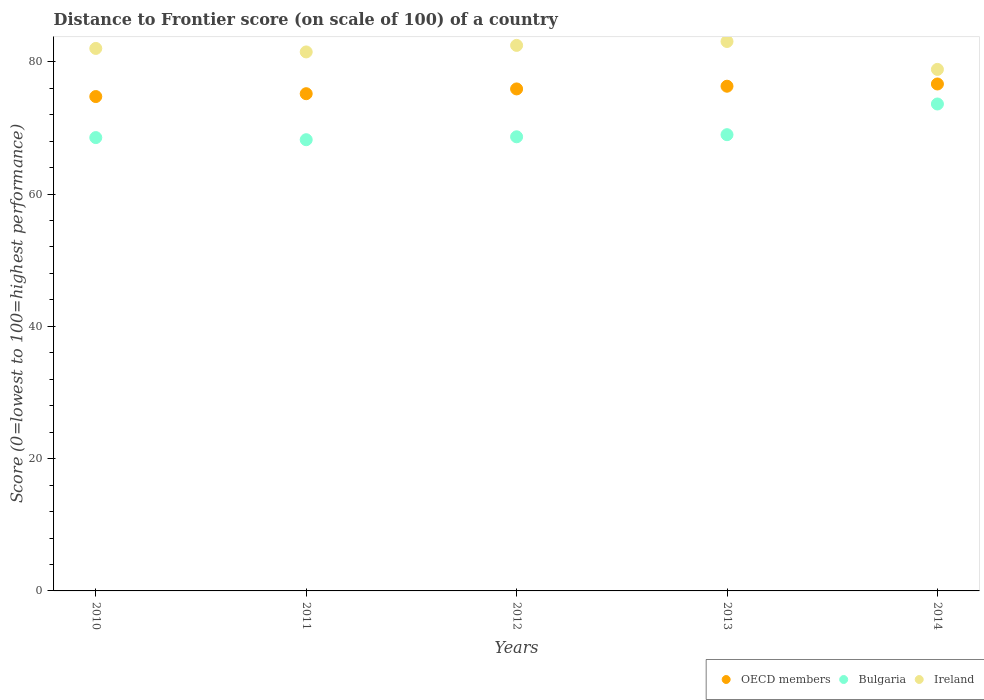What is the distance to frontier score of in Bulgaria in 2014?
Ensure brevity in your answer.  73.62. Across all years, what is the maximum distance to frontier score of in OECD members?
Give a very brief answer. 76.65. Across all years, what is the minimum distance to frontier score of in Bulgaria?
Keep it short and to the point. 68.22. In which year was the distance to frontier score of in OECD members minimum?
Provide a succinct answer. 2010. What is the total distance to frontier score of in OECD members in the graph?
Provide a short and direct response. 378.77. What is the difference between the distance to frontier score of in Bulgaria in 2012 and that in 2013?
Offer a terse response. -0.32. What is the difference between the distance to frontier score of in Ireland in 2011 and the distance to frontier score of in OECD members in 2012?
Provide a succinct answer. 5.59. What is the average distance to frontier score of in Bulgaria per year?
Provide a succinct answer. 69.6. In the year 2014, what is the difference between the distance to frontier score of in Ireland and distance to frontier score of in OECD members?
Your answer should be very brief. 2.2. In how many years, is the distance to frontier score of in OECD members greater than 36?
Offer a very short reply. 5. What is the ratio of the distance to frontier score of in Bulgaria in 2013 to that in 2014?
Your response must be concise. 0.94. Is the distance to frontier score of in OECD members in 2011 less than that in 2013?
Provide a succinct answer. Yes. Is the difference between the distance to frontier score of in Ireland in 2011 and 2012 greater than the difference between the distance to frontier score of in OECD members in 2011 and 2012?
Ensure brevity in your answer.  No. What is the difference between the highest and the second highest distance to frontier score of in OECD members?
Offer a terse response. 0.34. What is the difference between the highest and the lowest distance to frontier score of in Ireland?
Provide a short and direct response. 4.22. Is the sum of the distance to frontier score of in OECD members in 2010 and 2014 greater than the maximum distance to frontier score of in Ireland across all years?
Offer a very short reply. Yes. How many years are there in the graph?
Offer a terse response. 5. What is the difference between two consecutive major ticks on the Y-axis?
Keep it short and to the point. 20. Does the graph contain any zero values?
Make the answer very short. No. Where does the legend appear in the graph?
Your answer should be very brief. Bottom right. What is the title of the graph?
Ensure brevity in your answer.  Distance to Frontier score (on scale of 100) of a country. Does "Zambia" appear as one of the legend labels in the graph?
Offer a very short reply. No. What is the label or title of the Y-axis?
Provide a succinct answer. Score (0=lowest to 100=highest performance). What is the Score (0=lowest to 100=highest performance) in OECD members in 2010?
Your response must be concise. 74.74. What is the Score (0=lowest to 100=highest performance) of Bulgaria in 2010?
Offer a terse response. 68.54. What is the Score (0=lowest to 100=highest performance) of Ireland in 2010?
Your answer should be compact. 82.02. What is the Score (0=lowest to 100=highest performance) in OECD members in 2011?
Your response must be concise. 75.18. What is the Score (0=lowest to 100=highest performance) of Bulgaria in 2011?
Offer a terse response. 68.22. What is the Score (0=lowest to 100=highest performance) of Ireland in 2011?
Ensure brevity in your answer.  81.49. What is the Score (0=lowest to 100=highest performance) in OECD members in 2012?
Offer a very short reply. 75.9. What is the Score (0=lowest to 100=highest performance) of Bulgaria in 2012?
Offer a terse response. 68.66. What is the Score (0=lowest to 100=highest performance) in Ireland in 2012?
Provide a succinct answer. 82.48. What is the Score (0=lowest to 100=highest performance) of OECD members in 2013?
Provide a short and direct response. 76.31. What is the Score (0=lowest to 100=highest performance) in Bulgaria in 2013?
Make the answer very short. 68.98. What is the Score (0=lowest to 100=highest performance) of Ireland in 2013?
Your answer should be compact. 83.07. What is the Score (0=lowest to 100=highest performance) of OECD members in 2014?
Keep it short and to the point. 76.65. What is the Score (0=lowest to 100=highest performance) in Bulgaria in 2014?
Provide a short and direct response. 73.62. What is the Score (0=lowest to 100=highest performance) in Ireland in 2014?
Give a very brief answer. 78.85. Across all years, what is the maximum Score (0=lowest to 100=highest performance) in OECD members?
Your answer should be compact. 76.65. Across all years, what is the maximum Score (0=lowest to 100=highest performance) in Bulgaria?
Offer a terse response. 73.62. Across all years, what is the maximum Score (0=lowest to 100=highest performance) of Ireland?
Ensure brevity in your answer.  83.07. Across all years, what is the minimum Score (0=lowest to 100=highest performance) in OECD members?
Make the answer very short. 74.74. Across all years, what is the minimum Score (0=lowest to 100=highest performance) in Bulgaria?
Keep it short and to the point. 68.22. Across all years, what is the minimum Score (0=lowest to 100=highest performance) of Ireland?
Your response must be concise. 78.85. What is the total Score (0=lowest to 100=highest performance) in OECD members in the graph?
Ensure brevity in your answer.  378.77. What is the total Score (0=lowest to 100=highest performance) of Bulgaria in the graph?
Give a very brief answer. 348.02. What is the total Score (0=lowest to 100=highest performance) in Ireland in the graph?
Ensure brevity in your answer.  407.91. What is the difference between the Score (0=lowest to 100=highest performance) of OECD members in 2010 and that in 2011?
Offer a terse response. -0.43. What is the difference between the Score (0=lowest to 100=highest performance) of Bulgaria in 2010 and that in 2011?
Offer a terse response. 0.32. What is the difference between the Score (0=lowest to 100=highest performance) in Ireland in 2010 and that in 2011?
Your answer should be very brief. 0.53. What is the difference between the Score (0=lowest to 100=highest performance) in OECD members in 2010 and that in 2012?
Your response must be concise. -1.15. What is the difference between the Score (0=lowest to 100=highest performance) in Bulgaria in 2010 and that in 2012?
Keep it short and to the point. -0.12. What is the difference between the Score (0=lowest to 100=highest performance) in Ireland in 2010 and that in 2012?
Provide a short and direct response. -0.46. What is the difference between the Score (0=lowest to 100=highest performance) in OECD members in 2010 and that in 2013?
Give a very brief answer. -1.56. What is the difference between the Score (0=lowest to 100=highest performance) of Bulgaria in 2010 and that in 2013?
Offer a terse response. -0.44. What is the difference between the Score (0=lowest to 100=highest performance) of Ireland in 2010 and that in 2013?
Provide a short and direct response. -1.05. What is the difference between the Score (0=lowest to 100=highest performance) in OECD members in 2010 and that in 2014?
Ensure brevity in your answer.  -1.9. What is the difference between the Score (0=lowest to 100=highest performance) in Bulgaria in 2010 and that in 2014?
Keep it short and to the point. -5.08. What is the difference between the Score (0=lowest to 100=highest performance) in Ireland in 2010 and that in 2014?
Make the answer very short. 3.17. What is the difference between the Score (0=lowest to 100=highest performance) of OECD members in 2011 and that in 2012?
Offer a very short reply. -0.72. What is the difference between the Score (0=lowest to 100=highest performance) in Bulgaria in 2011 and that in 2012?
Provide a succinct answer. -0.44. What is the difference between the Score (0=lowest to 100=highest performance) of Ireland in 2011 and that in 2012?
Keep it short and to the point. -0.99. What is the difference between the Score (0=lowest to 100=highest performance) in OECD members in 2011 and that in 2013?
Offer a very short reply. -1.13. What is the difference between the Score (0=lowest to 100=highest performance) of Bulgaria in 2011 and that in 2013?
Your answer should be very brief. -0.76. What is the difference between the Score (0=lowest to 100=highest performance) in Ireland in 2011 and that in 2013?
Ensure brevity in your answer.  -1.58. What is the difference between the Score (0=lowest to 100=highest performance) of OECD members in 2011 and that in 2014?
Your response must be concise. -1.47. What is the difference between the Score (0=lowest to 100=highest performance) in Bulgaria in 2011 and that in 2014?
Give a very brief answer. -5.4. What is the difference between the Score (0=lowest to 100=highest performance) of Ireland in 2011 and that in 2014?
Make the answer very short. 2.64. What is the difference between the Score (0=lowest to 100=highest performance) of OECD members in 2012 and that in 2013?
Your response must be concise. -0.41. What is the difference between the Score (0=lowest to 100=highest performance) of Bulgaria in 2012 and that in 2013?
Provide a succinct answer. -0.32. What is the difference between the Score (0=lowest to 100=highest performance) of Ireland in 2012 and that in 2013?
Offer a very short reply. -0.59. What is the difference between the Score (0=lowest to 100=highest performance) in OECD members in 2012 and that in 2014?
Give a very brief answer. -0.75. What is the difference between the Score (0=lowest to 100=highest performance) in Bulgaria in 2012 and that in 2014?
Offer a very short reply. -4.96. What is the difference between the Score (0=lowest to 100=highest performance) of Ireland in 2012 and that in 2014?
Offer a very short reply. 3.63. What is the difference between the Score (0=lowest to 100=highest performance) of OECD members in 2013 and that in 2014?
Offer a very short reply. -0.34. What is the difference between the Score (0=lowest to 100=highest performance) of Bulgaria in 2013 and that in 2014?
Ensure brevity in your answer.  -4.64. What is the difference between the Score (0=lowest to 100=highest performance) of Ireland in 2013 and that in 2014?
Offer a terse response. 4.22. What is the difference between the Score (0=lowest to 100=highest performance) of OECD members in 2010 and the Score (0=lowest to 100=highest performance) of Bulgaria in 2011?
Your response must be concise. 6.52. What is the difference between the Score (0=lowest to 100=highest performance) of OECD members in 2010 and the Score (0=lowest to 100=highest performance) of Ireland in 2011?
Your answer should be very brief. -6.75. What is the difference between the Score (0=lowest to 100=highest performance) of Bulgaria in 2010 and the Score (0=lowest to 100=highest performance) of Ireland in 2011?
Provide a succinct answer. -12.95. What is the difference between the Score (0=lowest to 100=highest performance) in OECD members in 2010 and the Score (0=lowest to 100=highest performance) in Bulgaria in 2012?
Your response must be concise. 6.08. What is the difference between the Score (0=lowest to 100=highest performance) of OECD members in 2010 and the Score (0=lowest to 100=highest performance) of Ireland in 2012?
Keep it short and to the point. -7.74. What is the difference between the Score (0=lowest to 100=highest performance) in Bulgaria in 2010 and the Score (0=lowest to 100=highest performance) in Ireland in 2012?
Your answer should be compact. -13.94. What is the difference between the Score (0=lowest to 100=highest performance) of OECD members in 2010 and the Score (0=lowest to 100=highest performance) of Bulgaria in 2013?
Offer a terse response. 5.76. What is the difference between the Score (0=lowest to 100=highest performance) in OECD members in 2010 and the Score (0=lowest to 100=highest performance) in Ireland in 2013?
Give a very brief answer. -8.33. What is the difference between the Score (0=lowest to 100=highest performance) of Bulgaria in 2010 and the Score (0=lowest to 100=highest performance) of Ireland in 2013?
Offer a very short reply. -14.53. What is the difference between the Score (0=lowest to 100=highest performance) in OECD members in 2010 and the Score (0=lowest to 100=highest performance) in Bulgaria in 2014?
Keep it short and to the point. 1.12. What is the difference between the Score (0=lowest to 100=highest performance) in OECD members in 2010 and the Score (0=lowest to 100=highest performance) in Ireland in 2014?
Keep it short and to the point. -4.11. What is the difference between the Score (0=lowest to 100=highest performance) of Bulgaria in 2010 and the Score (0=lowest to 100=highest performance) of Ireland in 2014?
Ensure brevity in your answer.  -10.31. What is the difference between the Score (0=lowest to 100=highest performance) in OECD members in 2011 and the Score (0=lowest to 100=highest performance) in Bulgaria in 2012?
Your answer should be compact. 6.52. What is the difference between the Score (0=lowest to 100=highest performance) in OECD members in 2011 and the Score (0=lowest to 100=highest performance) in Ireland in 2012?
Your response must be concise. -7.3. What is the difference between the Score (0=lowest to 100=highest performance) of Bulgaria in 2011 and the Score (0=lowest to 100=highest performance) of Ireland in 2012?
Ensure brevity in your answer.  -14.26. What is the difference between the Score (0=lowest to 100=highest performance) in OECD members in 2011 and the Score (0=lowest to 100=highest performance) in Bulgaria in 2013?
Give a very brief answer. 6.2. What is the difference between the Score (0=lowest to 100=highest performance) of OECD members in 2011 and the Score (0=lowest to 100=highest performance) of Ireland in 2013?
Give a very brief answer. -7.89. What is the difference between the Score (0=lowest to 100=highest performance) in Bulgaria in 2011 and the Score (0=lowest to 100=highest performance) in Ireland in 2013?
Your answer should be very brief. -14.85. What is the difference between the Score (0=lowest to 100=highest performance) of OECD members in 2011 and the Score (0=lowest to 100=highest performance) of Bulgaria in 2014?
Your answer should be compact. 1.56. What is the difference between the Score (0=lowest to 100=highest performance) of OECD members in 2011 and the Score (0=lowest to 100=highest performance) of Ireland in 2014?
Keep it short and to the point. -3.67. What is the difference between the Score (0=lowest to 100=highest performance) of Bulgaria in 2011 and the Score (0=lowest to 100=highest performance) of Ireland in 2014?
Your response must be concise. -10.63. What is the difference between the Score (0=lowest to 100=highest performance) in OECD members in 2012 and the Score (0=lowest to 100=highest performance) in Bulgaria in 2013?
Your answer should be very brief. 6.92. What is the difference between the Score (0=lowest to 100=highest performance) of OECD members in 2012 and the Score (0=lowest to 100=highest performance) of Ireland in 2013?
Your response must be concise. -7.17. What is the difference between the Score (0=lowest to 100=highest performance) of Bulgaria in 2012 and the Score (0=lowest to 100=highest performance) of Ireland in 2013?
Make the answer very short. -14.41. What is the difference between the Score (0=lowest to 100=highest performance) in OECD members in 2012 and the Score (0=lowest to 100=highest performance) in Bulgaria in 2014?
Make the answer very short. 2.28. What is the difference between the Score (0=lowest to 100=highest performance) of OECD members in 2012 and the Score (0=lowest to 100=highest performance) of Ireland in 2014?
Ensure brevity in your answer.  -2.95. What is the difference between the Score (0=lowest to 100=highest performance) in Bulgaria in 2012 and the Score (0=lowest to 100=highest performance) in Ireland in 2014?
Offer a very short reply. -10.19. What is the difference between the Score (0=lowest to 100=highest performance) in OECD members in 2013 and the Score (0=lowest to 100=highest performance) in Bulgaria in 2014?
Make the answer very short. 2.69. What is the difference between the Score (0=lowest to 100=highest performance) in OECD members in 2013 and the Score (0=lowest to 100=highest performance) in Ireland in 2014?
Offer a terse response. -2.54. What is the difference between the Score (0=lowest to 100=highest performance) of Bulgaria in 2013 and the Score (0=lowest to 100=highest performance) of Ireland in 2014?
Offer a very short reply. -9.87. What is the average Score (0=lowest to 100=highest performance) of OECD members per year?
Make the answer very short. 75.75. What is the average Score (0=lowest to 100=highest performance) of Bulgaria per year?
Ensure brevity in your answer.  69.6. What is the average Score (0=lowest to 100=highest performance) of Ireland per year?
Make the answer very short. 81.58. In the year 2010, what is the difference between the Score (0=lowest to 100=highest performance) in OECD members and Score (0=lowest to 100=highest performance) in Bulgaria?
Provide a short and direct response. 6.2. In the year 2010, what is the difference between the Score (0=lowest to 100=highest performance) in OECD members and Score (0=lowest to 100=highest performance) in Ireland?
Keep it short and to the point. -7.28. In the year 2010, what is the difference between the Score (0=lowest to 100=highest performance) of Bulgaria and Score (0=lowest to 100=highest performance) of Ireland?
Ensure brevity in your answer.  -13.48. In the year 2011, what is the difference between the Score (0=lowest to 100=highest performance) of OECD members and Score (0=lowest to 100=highest performance) of Bulgaria?
Make the answer very short. 6.96. In the year 2011, what is the difference between the Score (0=lowest to 100=highest performance) of OECD members and Score (0=lowest to 100=highest performance) of Ireland?
Offer a very short reply. -6.31. In the year 2011, what is the difference between the Score (0=lowest to 100=highest performance) in Bulgaria and Score (0=lowest to 100=highest performance) in Ireland?
Offer a very short reply. -13.27. In the year 2012, what is the difference between the Score (0=lowest to 100=highest performance) of OECD members and Score (0=lowest to 100=highest performance) of Bulgaria?
Keep it short and to the point. 7.24. In the year 2012, what is the difference between the Score (0=lowest to 100=highest performance) of OECD members and Score (0=lowest to 100=highest performance) of Ireland?
Give a very brief answer. -6.58. In the year 2012, what is the difference between the Score (0=lowest to 100=highest performance) of Bulgaria and Score (0=lowest to 100=highest performance) of Ireland?
Ensure brevity in your answer.  -13.82. In the year 2013, what is the difference between the Score (0=lowest to 100=highest performance) in OECD members and Score (0=lowest to 100=highest performance) in Bulgaria?
Your answer should be compact. 7.33. In the year 2013, what is the difference between the Score (0=lowest to 100=highest performance) of OECD members and Score (0=lowest to 100=highest performance) of Ireland?
Provide a short and direct response. -6.76. In the year 2013, what is the difference between the Score (0=lowest to 100=highest performance) of Bulgaria and Score (0=lowest to 100=highest performance) of Ireland?
Provide a succinct answer. -14.09. In the year 2014, what is the difference between the Score (0=lowest to 100=highest performance) in OECD members and Score (0=lowest to 100=highest performance) in Bulgaria?
Give a very brief answer. 3.03. In the year 2014, what is the difference between the Score (0=lowest to 100=highest performance) in OECD members and Score (0=lowest to 100=highest performance) in Ireland?
Your response must be concise. -2.2. In the year 2014, what is the difference between the Score (0=lowest to 100=highest performance) in Bulgaria and Score (0=lowest to 100=highest performance) in Ireland?
Ensure brevity in your answer.  -5.23. What is the ratio of the Score (0=lowest to 100=highest performance) in Ireland in 2010 to that in 2011?
Provide a succinct answer. 1.01. What is the ratio of the Score (0=lowest to 100=highest performance) of OECD members in 2010 to that in 2012?
Provide a short and direct response. 0.98. What is the ratio of the Score (0=lowest to 100=highest performance) of Bulgaria in 2010 to that in 2012?
Your answer should be compact. 1. What is the ratio of the Score (0=lowest to 100=highest performance) of OECD members in 2010 to that in 2013?
Your answer should be compact. 0.98. What is the ratio of the Score (0=lowest to 100=highest performance) in Ireland in 2010 to that in 2013?
Keep it short and to the point. 0.99. What is the ratio of the Score (0=lowest to 100=highest performance) in OECD members in 2010 to that in 2014?
Make the answer very short. 0.98. What is the ratio of the Score (0=lowest to 100=highest performance) of Bulgaria in 2010 to that in 2014?
Keep it short and to the point. 0.93. What is the ratio of the Score (0=lowest to 100=highest performance) of Ireland in 2010 to that in 2014?
Make the answer very short. 1.04. What is the ratio of the Score (0=lowest to 100=highest performance) in OECD members in 2011 to that in 2013?
Your answer should be very brief. 0.99. What is the ratio of the Score (0=lowest to 100=highest performance) of OECD members in 2011 to that in 2014?
Give a very brief answer. 0.98. What is the ratio of the Score (0=lowest to 100=highest performance) of Bulgaria in 2011 to that in 2014?
Give a very brief answer. 0.93. What is the ratio of the Score (0=lowest to 100=highest performance) of Ireland in 2011 to that in 2014?
Provide a succinct answer. 1.03. What is the ratio of the Score (0=lowest to 100=highest performance) in OECD members in 2012 to that in 2013?
Keep it short and to the point. 0.99. What is the ratio of the Score (0=lowest to 100=highest performance) in OECD members in 2012 to that in 2014?
Your answer should be compact. 0.99. What is the ratio of the Score (0=lowest to 100=highest performance) of Bulgaria in 2012 to that in 2014?
Offer a very short reply. 0.93. What is the ratio of the Score (0=lowest to 100=highest performance) of Ireland in 2012 to that in 2014?
Provide a short and direct response. 1.05. What is the ratio of the Score (0=lowest to 100=highest performance) of OECD members in 2013 to that in 2014?
Give a very brief answer. 1. What is the ratio of the Score (0=lowest to 100=highest performance) of Bulgaria in 2013 to that in 2014?
Provide a short and direct response. 0.94. What is the ratio of the Score (0=lowest to 100=highest performance) of Ireland in 2013 to that in 2014?
Keep it short and to the point. 1.05. What is the difference between the highest and the second highest Score (0=lowest to 100=highest performance) of OECD members?
Ensure brevity in your answer.  0.34. What is the difference between the highest and the second highest Score (0=lowest to 100=highest performance) of Bulgaria?
Give a very brief answer. 4.64. What is the difference between the highest and the second highest Score (0=lowest to 100=highest performance) in Ireland?
Your answer should be very brief. 0.59. What is the difference between the highest and the lowest Score (0=lowest to 100=highest performance) in OECD members?
Keep it short and to the point. 1.9. What is the difference between the highest and the lowest Score (0=lowest to 100=highest performance) in Ireland?
Provide a short and direct response. 4.22. 